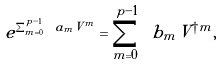<formula> <loc_0><loc_0><loc_500><loc_500>e ^ { \sum _ { m = 0 } ^ { p - 1 } \ a _ { m } V ^ { m } } = \sum _ { m = 0 } ^ { p - 1 } \ b _ { m } V ^ { \dagger m } ,</formula> 